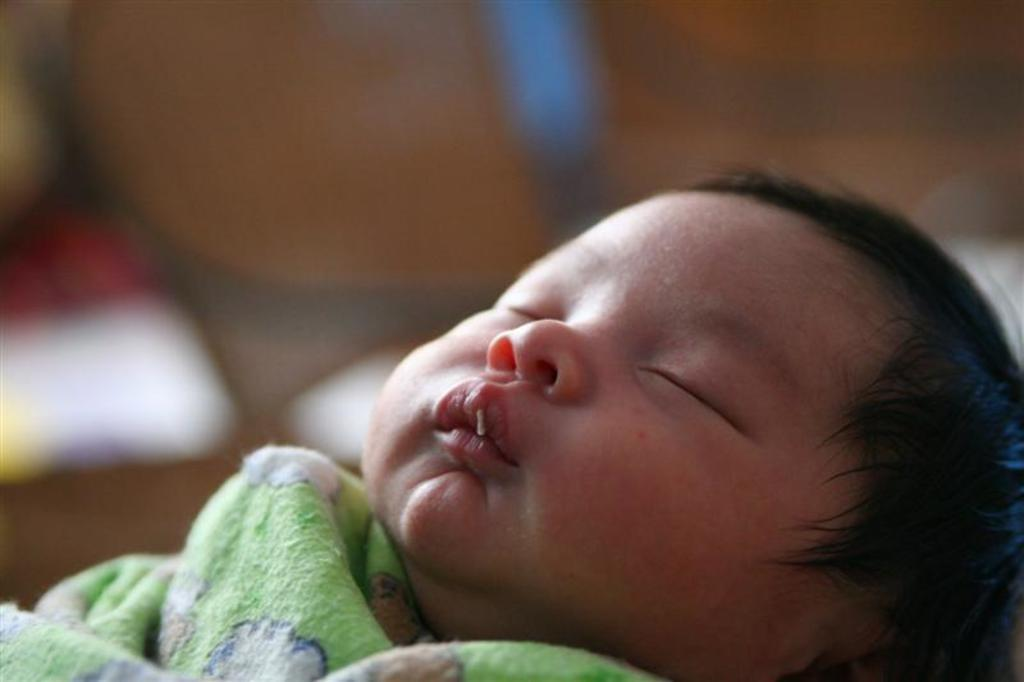What is the main subject of the image? There is a baby in the center of the image. What is the baby doing in the image? The baby is sleeping. What is the baby wearing in the image? The baby is wearing clothes. How would you describe the background of the image? The background of the image is blurry. What type of farming equipment can be seen in the background of the image? There is no farming equipment present in the image; it features a baby sleeping in the center. Is there a crib visible in the image? There is no crib visible in the image; the baby is in the center of the image. 